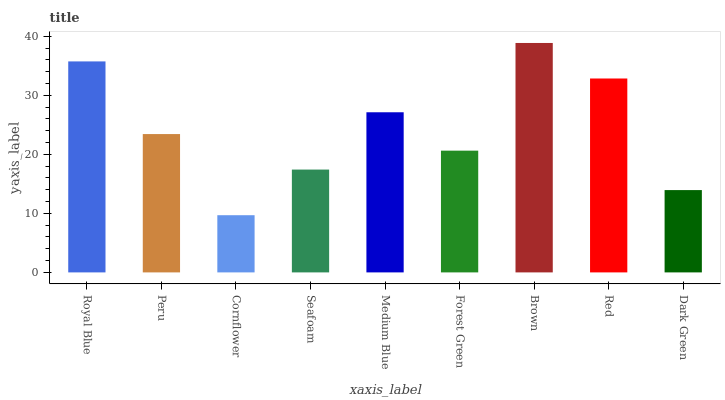Is Peru the minimum?
Answer yes or no. No. Is Peru the maximum?
Answer yes or no. No. Is Royal Blue greater than Peru?
Answer yes or no. Yes. Is Peru less than Royal Blue?
Answer yes or no. Yes. Is Peru greater than Royal Blue?
Answer yes or no. No. Is Royal Blue less than Peru?
Answer yes or no. No. Is Peru the high median?
Answer yes or no. Yes. Is Peru the low median?
Answer yes or no. Yes. Is Cornflower the high median?
Answer yes or no. No. Is Seafoam the low median?
Answer yes or no. No. 